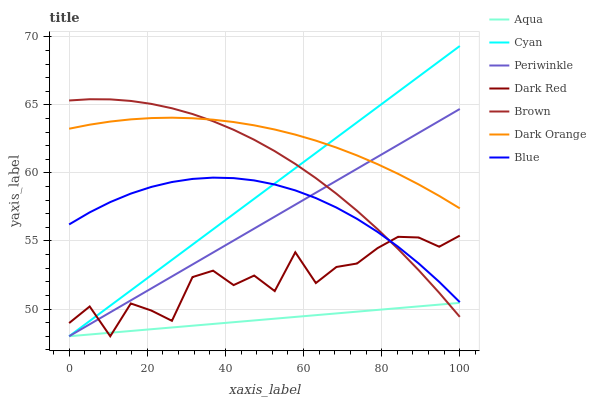Does Aqua have the minimum area under the curve?
Answer yes or no. Yes. Does Dark Orange have the maximum area under the curve?
Answer yes or no. Yes. Does Brown have the minimum area under the curve?
Answer yes or no. No. Does Brown have the maximum area under the curve?
Answer yes or no. No. Is Periwinkle the smoothest?
Answer yes or no. Yes. Is Dark Red the roughest?
Answer yes or no. Yes. Is Dark Orange the smoothest?
Answer yes or no. No. Is Dark Orange the roughest?
Answer yes or no. No. Does Dark Red have the lowest value?
Answer yes or no. Yes. Does Brown have the lowest value?
Answer yes or no. No. Does Cyan have the highest value?
Answer yes or no. Yes. Does Dark Orange have the highest value?
Answer yes or no. No. Is Aqua less than Blue?
Answer yes or no. Yes. Is Blue greater than Aqua?
Answer yes or no. Yes. Does Periwinkle intersect Blue?
Answer yes or no. Yes. Is Periwinkle less than Blue?
Answer yes or no. No. Is Periwinkle greater than Blue?
Answer yes or no. No. Does Aqua intersect Blue?
Answer yes or no. No. 